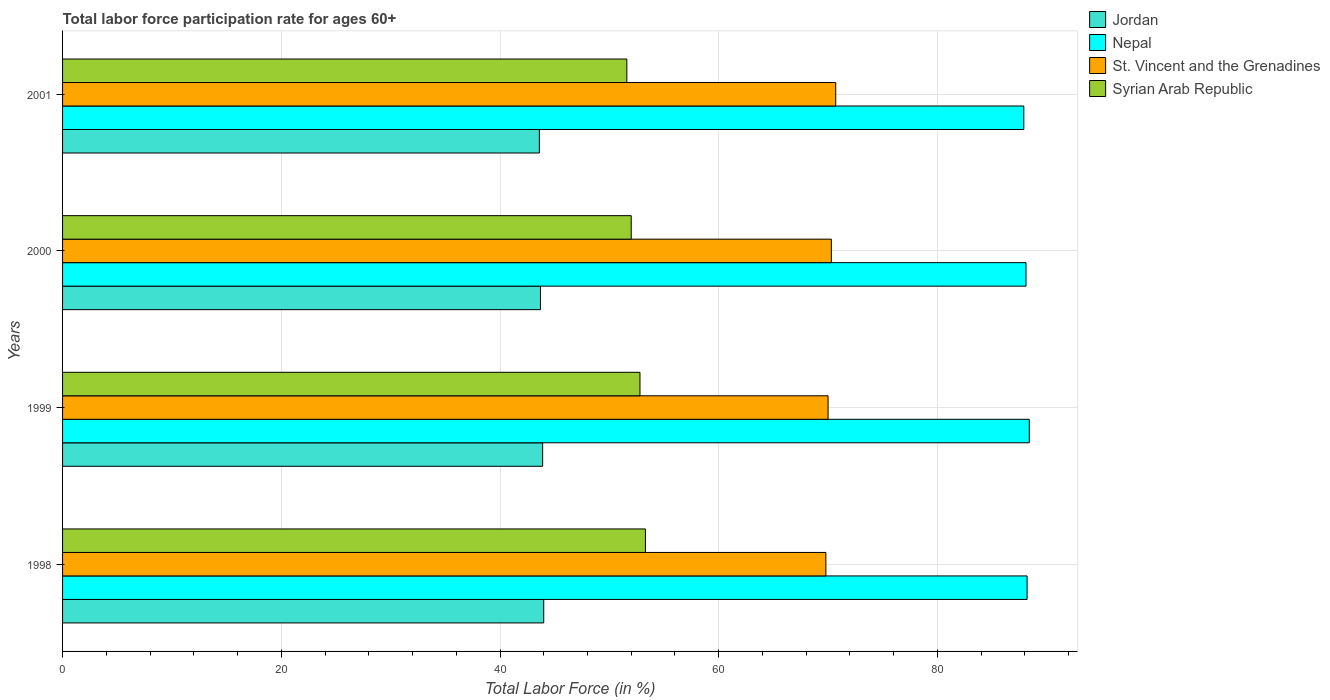How many groups of bars are there?
Keep it short and to the point. 4. Are the number of bars on each tick of the Y-axis equal?
Ensure brevity in your answer.  Yes. How many bars are there on the 3rd tick from the top?
Offer a terse response. 4. How many bars are there on the 4th tick from the bottom?
Give a very brief answer. 4. What is the label of the 1st group of bars from the top?
Provide a short and direct response. 2001. What is the labor force participation rate in Jordan in 1999?
Your answer should be compact. 43.9. Across all years, what is the maximum labor force participation rate in Syrian Arab Republic?
Offer a very short reply. 53.3. Across all years, what is the minimum labor force participation rate in Jordan?
Offer a very short reply. 43.6. In which year was the labor force participation rate in Jordan maximum?
Your answer should be very brief. 1998. In which year was the labor force participation rate in St. Vincent and the Grenadines minimum?
Offer a terse response. 1998. What is the total labor force participation rate in Jordan in the graph?
Offer a very short reply. 175.2. What is the difference between the labor force participation rate in Jordan in 1998 and that in 2001?
Provide a short and direct response. 0.4. What is the difference between the labor force participation rate in St. Vincent and the Grenadines in 1998 and the labor force participation rate in Syrian Arab Republic in 2001?
Offer a terse response. 18.2. What is the average labor force participation rate in St. Vincent and the Grenadines per year?
Give a very brief answer. 70.2. In the year 1998, what is the difference between the labor force participation rate in Nepal and labor force participation rate in Syrian Arab Republic?
Your answer should be compact. 34.9. What is the ratio of the labor force participation rate in Syrian Arab Republic in 1998 to that in 2001?
Offer a very short reply. 1.03. Is the labor force participation rate in Jordan in 1998 less than that in 2001?
Your answer should be compact. No. Is the sum of the labor force participation rate in Jordan in 1999 and 2000 greater than the maximum labor force participation rate in Nepal across all years?
Keep it short and to the point. No. Is it the case that in every year, the sum of the labor force participation rate in St. Vincent and the Grenadines and labor force participation rate in Jordan is greater than the sum of labor force participation rate in Nepal and labor force participation rate in Syrian Arab Republic?
Keep it short and to the point. Yes. What does the 2nd bar from the top in 1998 represents?
Your answer should be very brief. St. Vincent and the Grenadines. What does the 1st bar from the bottom in 1998 represents?
Offer a very short reply. Jordan. Are all the bars in the graph horizontal?
Provide a short and direct response. Yes. Does the graph contain any zero values?
Provide a succinct answer. No. Where does the legend appear in the graph?
Provide a succinct answer. Top right. How are the legend labels stacked?
Offer a terse response. Vertical. What is the title of the graph?
Ensure brevity in your answer.  Total labor force participation rate for ages 60+. What is the label or title of the Y-axis?
Make the answer very short. Years. What is the Total Labor Force (in %) in Jordan in 1998?
Your response must be concise. 44. What is the Total Labor Force (in %) in Nepal in 1998?
Your answer should be very brief. 88.2. What is the Total Labor Force (in %) of St. Vincent and the Grenadines in 1998?
Keep it short and to the point. 69.8. What is the Total Labor Force (in %) in Syrian Arab Republic in 1998?
Provide a succinct answer. 53.3. What is the Total Labor Force (in %) of Jordan in 1999?
Your answer should be very brief. 43.9. What is the Total Labor Force (in %) of Nepal in 1999?
Offer a terse response. 88.4. What is the Total Labor Force (in %) of St. Vincent and the Grenadines in 1999?
Make the answer very short. 70. What is the Total Labor Force (in %) of Syrian Arab Republic in 1999?
Your response must be concise. 52.8. What is the Total Labor Force (in %) in Jordan in 2000?
Ensure brevity in your answer.  43.7. What is the Total Labor Force (in %) in Nepal in 2000?
Provide a short and direct response. 88.1. What is the Total Labor Force (in %) in St. Vincent and the Grenadines in 2000?
Your answer should be very brief. 70.3. What is the Total Labor Force (in %) in Syrian Arab Republic in 2000?
Keep it short and to the point. 52. What is the Total Labor Force (in %) in Jordan in 2001?
Offer a terse response. 43.6. What is the Total Labor Force (in %) in Nepal in 2001?
Provide a succinct answer. 87.9. What is the Total Labor Force (in %) in St. Vincent and the Grenadines in 2001?
Keep it short and to the point. 70.7. What is the Total Labor Force (in %) of Syrian Arab Republic in 2001?
Ensure brevity in your answer.  51.6. Across all years, what is the maximum Total Labor Force (in %) of Jordan?
Offer a very short reply. 44. Across all years, what is the maximum Total Labor Force (in %) of Nepal?
Your answer should be compact. 88.4. Across all years, what is the maximum Total Labor Force (in %) in St. Vincent and the Grenadines?
Offer a very short reply. 70.7. Across all years, what is the maximum Total Labor Force (in %) in Syrian Arab Republic?
Make the answer very short. 53.3. Across all years, what is the minimum Total Labor Force (in %) in Jordan?
Offer a very short reply. 43.6. Across all years, what is the minimum Total Labor Force (in %) of Nepal?
Your answer should be very brief. 87.9. Across all years, what is the minimum Total Labor Force (in %) of St. Vincent and the Grenadines?
Provide a short and direct response. 69.8. Across all years, what is the minimum Total Labor Force (in %) in Syrian Arab Republic?
Ensure brevity in your answer.  51.6. What is the total Total Labor Force (in %) of Jordan in the graph?
Provide a succinct answer. 175.2. What is the total Total Labor Force (in %) of Nepal in the graph?
Offer a terse response. 352.6. What is the total Total Labor Force (in %) in St. Vincent and the Grenadines in the graph?
Your answer should be very brief. 280.8. What is the total Total Labor Force (in %) of Syrian Arab Republic in the graph?
Offer a terse response. 209.7. What is the difference between the Total Labor Force (in %) of Jordan in 1998 and that in 1999?
Offer a very short reply. 0.1. What is the difference between the Total Labor Force (in %) of Nepal in 1998 and that in 1999?
Offer a very short reply. -0.2. What is the difference between the Total Labor Force (in %) in St. Vincent and the Grenadines in 1998 and that in 1999?
Ensure brevity in your answer.  -0.2. What is the difference between the Total Labor Force (in %) in Nepal in 1998 and that in 2000?
Ensure brevity in your answer.  0.1. What is the difference between the Total Labor Force (in %) of St. Vincent and the Grenadines in 1998 and that in 2000?
Make the answer very short. -0.5. What is the difference between the Total Labor Force (in %) in Nepal in 1998 and that in 2001?
Make the answer very short. 0.3. What is the difference between the Total Labor Force (in %) in St. Vincent and the Grenadines in 1998 and that in 2001?
Offer a very short reply. -0.9. What is the difference between the Total Labor Force (in %) of Jordan in 1999 and that in 2000?
Give a very brief answer. 0.2. What is the difference between the Total Labor Force (in %) of Syrian Arab Republic in 1999 and that in 2000?
Your answer should be compact. 0.8. What is the difference between the Total Labor Force (in %) in Jordan in 1999 and that in 2001?
Your answer should be compact. 0.3. What is the difference between the Total Labor Force (in %) of Nepal in 1999 and that in 2001?
Your answer should be very brief. 0.5. What is the difference between the Total Labor Force (in %) of Jordan in 2000 and that in 2001?
Provide a short and direct response. 0.1. What is the difference between the Total Labor Force (in %) in St. Vincent and the Grenadines in 2000 and that in 2001?
Offer a terse response. -0.4. What is the difference between the Total Labor Force (in %) of Syrian Arab Republic in 2000 and that in 2001?
Your answer should be compact. 0.4. What is the difference between the Total Labor Force (in %) in Jordan in 1998 and the Total Labor Force (in %) in Nepal in 1999?
Provide a short and direct response. -44.4. What is the difference between the Total Labor Force (in %) in Jordan in 1998 and the Total Labor Force (in %) in Syrian Arab Republic in 1999?
Make the answer very short. -8.8. What is the difference between the Total Labor Force (in %) in Nepal in 1998 and the Total Labor Force (in %) in Syrian Arab Republic in 1999?
Give a very brief answer. 35.4. What is the difference between the Total Labor Force (in %) of St. Vincent and the Grenadines in 1998 and the Total Labor Force (in %) of Syrian Arab Republic in 1999?
Provide a short and direct response. 17. What is the difference between the Total Labor Force (in %) in Jordan in 1998 and the Total Labor Force (in %) in Nepal in 2000?
Make the answer very short. -44.1. What is the difference between the Total Labor Force (in %) of Jordan in 1998 and the Total Labor Force (in %) of St. Vincent and the Grenadines in 2000?
Your response must be concise. -26.3. What is the difference between the Total Labor Force (in %) in Jordan in 1998 and the Total Labor Force (in %) in Syrian Arab Republic in 2000?
Your answer should be compact. -8. What is the difference between the Total Labor Force (in %) in Nepal in 1998 and the Total Labor Force (in %) in St. Vincent and the Grenadines in 2000?
Your answer should be very brief. 17.9. What is the difference between the Total Labor Force (in %) in Nepal in 1998 and the Total Labor Force (in %) in Syrian Arab Republic in 2000?
Make the answer very short. 36.2. What is the difference between the Total Labor Force (in %) of St. Vincent and the Grenadines in 1998 and the Total Labor Force (in %) of Syrian Arab Republic in 2000?
Your answer should be very brief. 17.8. What is the difference between the Total Labor Force (in %) in Jordan in 1998 and the Total Labor Force (in %) in Nepal in 2001?
Offer a very short reply. -43.9. What is the difference between the Total Labor Force (in %) in Jordan in 1998 and the Total Labor Force (in %) in St. Vincent and the Grenadines in 2001?
Ensure brevity in your answer.  -26.7. What is the difference between the Total Labor Force (in %) in Nepal in 1998 and the Total Labor Force (in %) in St. Vincent and the Grenadines in 2001?
Keep it short and to the point. 17.5. What is the difference between the Total Labor Force (in %) of Nepal in 1998 and the Total Labor Force (in %) of Syrian Arab Republic in 2001?
Provide a succinct answer. 36.6. What is the difference between the Total Labor Force (in %) of St. Vincent and the Grenadines in 1998 and the Total Labor Force (in %) of Syrian Arab Republic in 2001?
Make the answer very short. 18.2. What is the difference between the Total Labor Force (in %) in Jordan in 1999 and the Total Labor Force (in %) in Nepal in 2000?
Offer a very short reply. -44.2. What is the difference between the Total Labor Force (in %) of Jordan in 1999 and the Total Labor Force (in %) of St. Vincent and the Grenadines in 2000?
Your answer should be compact. -26.4. What is the difference between the Total Labor Force (in %) of Nepal in 1999 and the Total Labor Force (in %) of Syrian Arab Republic in 2000?
Offer a very short reply. 36.4. What is the difference between the Total Labor Force (in %) of St. Vincent and the Grenadines in 1999 and the Total Labor Force (in %) of Syrian Arab Republic in 2000?
Keep it short and to the point. 18. What is the difference between the Total Labor Force (in %) in Jordan in 1999 and the Total Labor Force (in %) in Nepal in 2001?
Provide a succinct answer. -44. What is the difference between the Total Labor Force (in %) in Jordan in 1999 and the Total Labor Force (in %) in St. Vincent and the Grenadines in 2001?
Give a very brief answer. -26.8. What is the difference between the Total Labor Force (in %) in Nepal in 1999 and the Total Labor Force (in %) in Syrian Arab Republic in 2001?
Provide a succinct answer. 36.8. What is the difference between the Total Labor Force (in %) in St. Vincent and the Grenadines in 1999 and the Total Labor Force (in %) in Syrian Arab Republic in 2001?
Your answer should be compact. 18.4. What is the difference between the Total Labor Force (in %) of Jordan in 2000 and the Total Labor Force (in %) of Nepal in 2001?
Provide a succinct answer. -44.2. What is the difference between the Total Labor Force (in %) of Nepal in 2000 and the Total Labor Force (in %) of St. Vincent and the Grenadines in 2001?
Provide a short and direct response. 17.4. What is the difference between the Total Labor Force (in %) in Nepal in 2000 and the Total Labor Force (in %) in Syrian Arab Republic in 2001?
Your response must be concise. 36.5. What is the average Total Labor Force (in %) of Jordan per year?
Your answer should be compact. 43.8. What is the average Total Labor Force (in %) in Nepal per year?
Your answer should be compact. 88.15. What is the average Total Labor Force (in %) of St. Vincent and the Grenadines per year?
Ensure brevity in your answer.  70.2. What is the average Total Labor Force (in %) in Syrian Arab Republic per year?
Provide a succinct answer. 52.42. In the year 1998, what is the difference between the Total Labor Force (in %) of Jordan and Total Labor Force (in %) of Nepal?
Your answer should be very brief. -44.2. In the year 1998, what is the difference between the Total Labor Force (in %) in Jordan and Total Labor Force (in %) in St. Vincent and the Grenadines?
Ensure brevity in your answer.  -25.8. In the year 1998, what is the difference between the Total Labor Force (in %) of Nepal and Total Labor Force (in %) of St. Vincent and the Grenadines?
Give a very brief answer. 18.4. In the year 1998, what is the difference between the Total Labor Force (in %) in Nepal and Total Labor Force (in %) in Syrian Arab Republic?
Offer a terse response. 34.9. In the year 1998, what is the difference between the Total Labor Force (in %) of St. Vincent and the Grenadines and Total Labor Force (in %) of Syrian Arab Republic?
Provide a short and direct response. 16.5. In the year 1999, what is the difference between the Total Labor Force (in %) of Jordan and Total Labor Force (in %) of Nepal?
Give a very brief answer. -44.5. In the year 1999, what is the difference between the Total Labor Force (in %) in Jordan and Total Labor Force (in %) in St. Vincent and the Grenadines?
Provide a short and direct response. -26.1. In the year 1999, what is the difference between the Total Labor Force (in %) in Jordan and Total Labor Force (in %) in Syrian Arab Republic?
Ensure brevity in your answer.  -8.9. In the year 1999, what is the difference between the Total Labor Force (in %) in Nepal and Total Labor Force (in %) in Syrian Arab Republic?
Keep it short and to the point. 35.6. In the year 1999, what is the difference between the Total Labor Force (in %) in St. Vincent and the Grenadines and Total Labor Force (in %) in Syrian Arab Republic?
Provide a succinct answer. 17.2. In the year 2000, what is the difference between the Total Labor Force (in %) of Jordan and Total Labor Force (in %) of Nepal?
Make the answer very short. -44.4. In the year 2000, what is the difference between the Total Labor Force (in %) in Jordan and Total Labor Force (in %) in St. Vincent and the Grenadines?
Make the answer very short. -26.6. In the year 2000, what is the difference between the Total Labor Force (in %) in Jordan and Total Labor Force (in %) in Syrian Arab Republic?
Your answer should be very brief. -8.3. In the year 2000, what is the difference between the Total Labor Force (in %) of Nepal and Total Labor Force (in %) of St. Vincent and the Grenadines?
Your answer should be compact. 17.8. In the year 2000, what is the difference between the Total Labor Force (in %) in Nepal and Total Labor Force (in %) in Syrian Arab Republic?
Keep it short and to the point. 36.1. In the year 2000, what is the difference between the Total Labor Force (in %) of St. Vincent and the Grenadines and Total Labor Force (in %) of Syrian Arab Republic?
Give a very brief answer. 18.3. In the year 2001, what is the difference between the Total Labor Force (in %) in Jordan and Total Labor Force (in %) in Nepal?
Give a very brief answer. -44.3. In the year 2001, what is the difference between the Total Labor Force (in %) of Jordan and Total Labor Force (in %) of St. Vincent and the Grenadines?
Give a very brief answer. -27.1. In the year 2001, what is the difference between the Total Labor Force (in %) in Nepal and Total Labor Force (in %) in Syrian Arab Republic?
Offer a very short reply. 36.3. What is the ratio of the Total Labor Force (in %) of Jordan in 1998 to that in 1999?
Provide a succinct answer. 1. What is the ratio of the Total Labor Force (in %) in Nepal in 1998 to that in 1999?
Provide a succinct answer. 1. What is the ratio of the Total Labor Force (in %) of St. Vincent and the Grenadines in 1998 to that in 1999?
Your response must be concise. 1. What is the ratio of the Total Labor Force (in %) in Syrian Arab Republic in 1998 to that in 1999?
Your answer should be very brief. 1.01. What is the ratio of the Total Labor Force (in %) in St. Vincent and the Grenadines in 1998 to that in 2000?
Make the answer very short. 0.99. What is the ratio of the Total Labor Force (in %) of Syrian Arab Republic in 1998 to that in 2000?
Keep it short and to the point. 1.02. What is the ratio of the Total Labor Force (in %) of Jordan in 1998 to that in 2001?
Make the answer very short. 1.01. What is the ratio of the Total Labor Force (in %) of Nepal in 1998 to that in 2001?
Provide a succinct answer. 1. What is the ratio of the Total Labor Force (in %) in St. Vincent and the Grenadines in 1998 to that in 2001?
Make the answer very short. 0.99. What is the ratio of the Total Labor Force (in %) of Syrian Arab Republic in 1998 to that in 2001?
Your answer should be very brief. 1.03. What is the ratio of the Total Labor Force (in %) of Jordan in 1999 to that in 2000?
Give a very brief answer. 1. What is the ratio of the Total Labor Force (in %) of St. Vincent and the Grenadines in 1999 to that in 2000?
Give a very brief answer. 1. What is the ratio of the Total Labor Force (in %) in Syrian Arab Republic in 1999 to that in 2000?
Your answer should be compact. 1.02. What is the ratio of the Total Labor Force (in %) in Jordan in 1999 to that in 2001?
Keep it short and to the point. 1.01. What is the ratio of the Total Labor Force (in %) of Nepal in 1999 to that in 2001?
Your answer should be compact. 1.01. What is the ratio of the Total Labor Force (in %) of St. Vincent and the Grenadines in 1999 to that in 2001?
Ensure brevity in your answer.  0.99. What is the ratio of the Total Labor Force (in %) in Syrian Arab Republic in 1999 to that in 2001?
Provide a succinct answer. 1.02. What is the ratio of the Total Labor Force (in %) in Jordan in 2000 to that in 2001?
Ensure brevity in your answer.  1. What is the difference between the highest and the second highest Total Labor Force (in %) of Nepal?
Provide a short and direct response. 0.2. What is the difference between the highest and the second highest Total Labor Force (in %) of St. Vincent and the Grenadines?
Offer a very short reply. 0.4. What is the difference between the highest and the lowest Total Labor Force (in %) in Jordan?
Ensure brevity in your answer.  0.4. What is the difference between the highest and the lowest Total Labor Force (in %) in Nepal?
Keep it short and to the point. 0.5. 